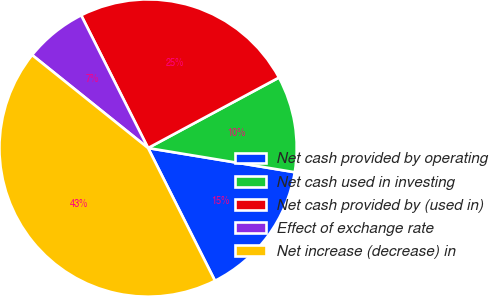Convert chart. <chart><loc_0><loc_0><loc_500><loc_500><pie_chart><fcel>Net cash provided by operating<fcel>Net cash used in investing<fcel>Net cash provided by (used in)<fcel>Effect of exchange rate<fcel>Net increase (decrease) in<nl><fcel>14.97%<fcel>10.46%<fcel>24.57%<fcel>6.81%<fcel>43.19%<nl></chart> 